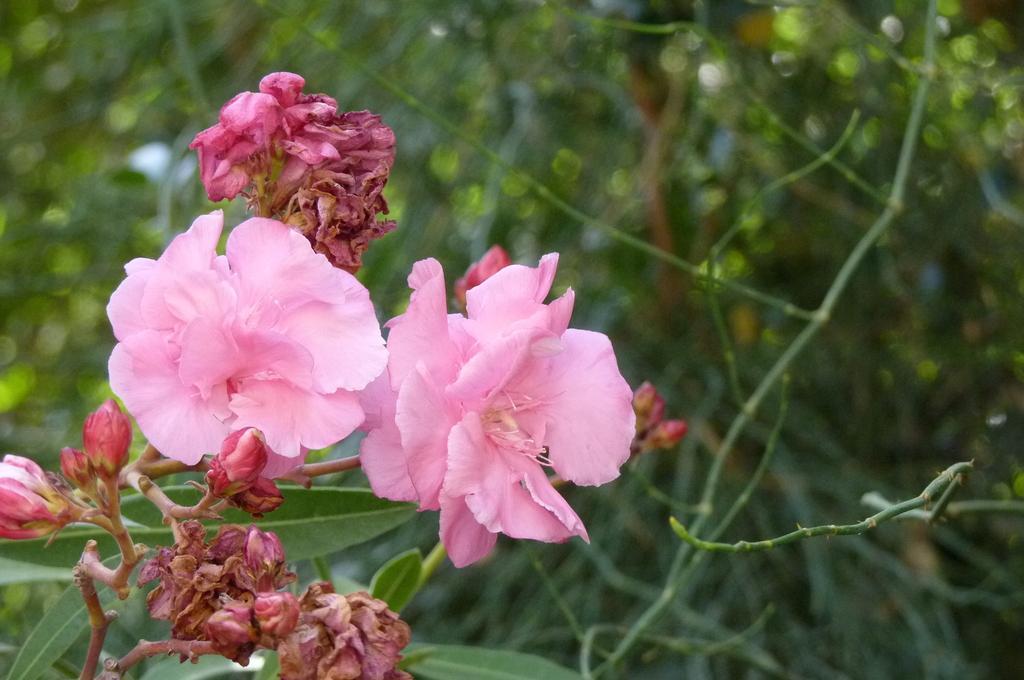Can you describe this image briefly? In this image on the left side I can see the flowers. In the background, I can see the plants. 